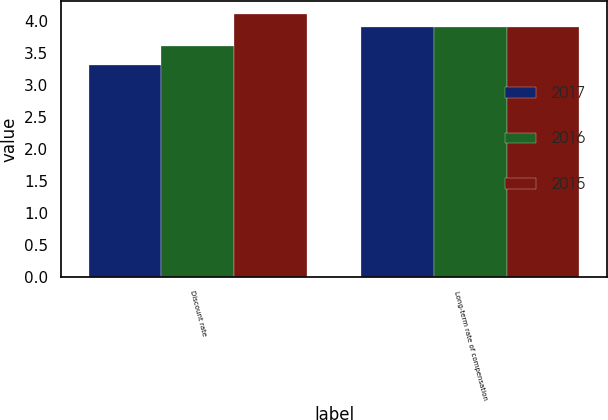<chart> <loc_0><loc_0><loc_500><loc_500><stacked_bar_chart><ecel><fcel>Discount rate<fcel>Long-term rate of compensation<nl><fcel>2017<fcel>3.3<fcel>3.9<nl><fcel>2016<fcel>3.6<fcel>3.9<nl><fcel>2015<fcel>4.1<fcel>3.9<nl></chart> 